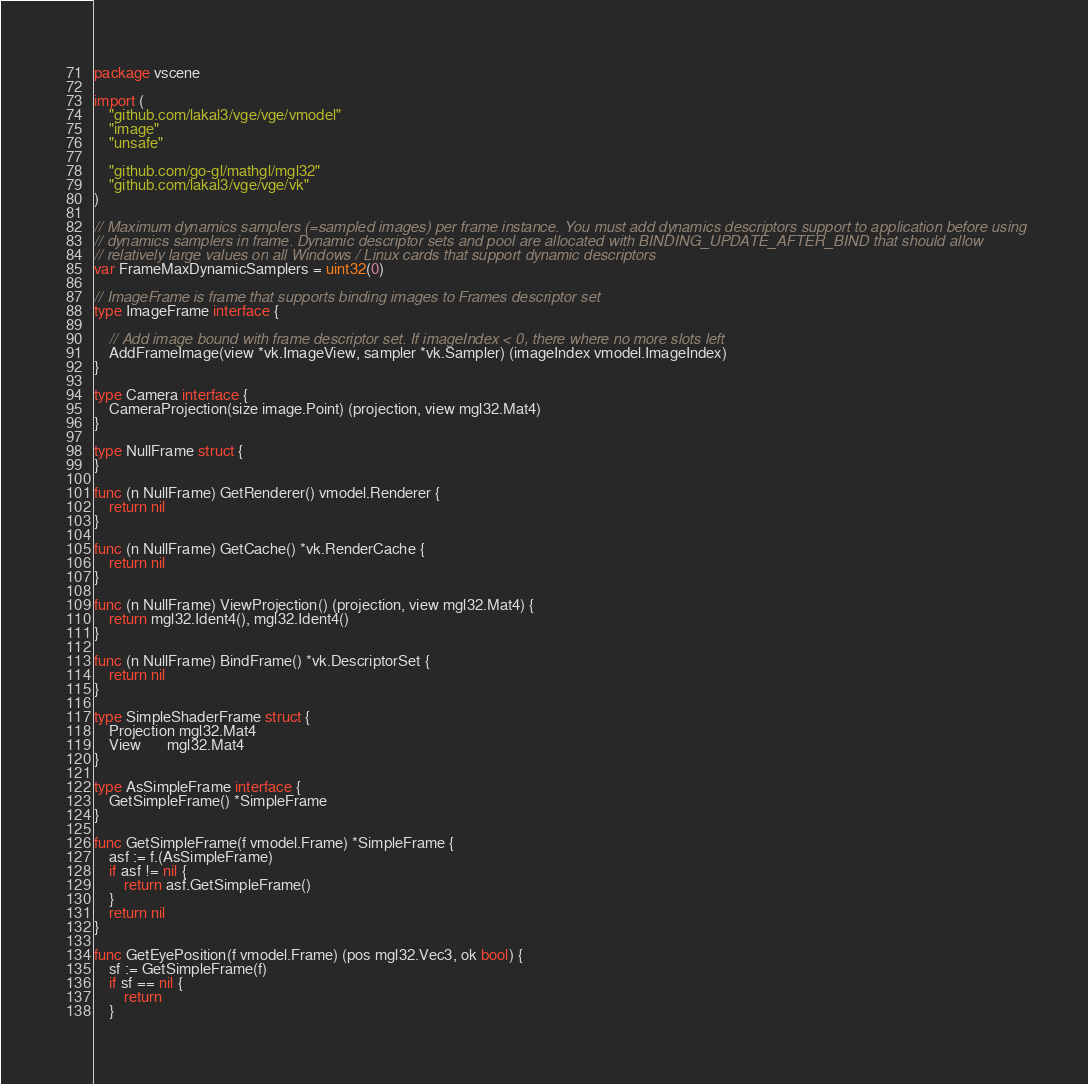Convert code to text. <code><loc_0><loc_0><loc_500><loc_500><_Go_>package vscene

import (
	"github.com/lakal3/vge/vge/vmodel"
	"image"
	"unsafe"

	"github.com/go-gl/mathgl/mgl32"
	"github.com/lakal3/vge/vge/vk"
)

// Maximum dynamics samplers (=sampled images) per frame instance. You must add dynamics descriptors support to application before using
// dynamics samplers in frame. Dynamic descriptor sets and pool are allocated with BINDING_UPDATE_AFTER_BIND that should allow
// relatively large values on all Windows / Linux cards that support dynamic descriptors
var FrameMaxDynamicSamplers = uint32(0)

// ImageFrame is frame that supports binding images to Frames descriptor set
type ImageFrame interface {

	// Add image bound with frame descriptor set. If imageIndex < 0, there where no more slots left
	AddFrameImage(view *vk.ImageView, sampler *vk.Sampler) (imageIndex vmodel.ImageIndex)
}

type Camera interface {
	CameraProjection(size image.Point) (projection, view mgl32.Mat4)
}

type NullFrame struct {
}

func (n NullFrame) GetRenderer() vmodel.Renderer {
	return nil
}

func (n NullFrame) GetCache() *vk.RenderCache {
	return nil
}

func (n NullFrame) ViewProjection() (projection, view mgl32.Mat4) {
	return mgl32.Ident4(), mgl32.Ident4()
}

func (n NullFrame) BindFrame() *vk.DescriptorSet {
	return nil
}

type SimpleShaderFrame struct {
	Projection mgl32.Mat4
	View       mgl32.Mat4
}

type AsSimpleFrame interface {
	GetSimpleFrame() *SimpleFrame
}

func GetSimpleFrame(f vmodel.Frame) *SimpleFrame {
	asf := f.(AsSimpleFrame)
	if asf != nil {
		return asf.GetSimpleFrame()
	}
	return nil
}

func GetEyePosition(f vmodel.Frame) (pos mgl32.Vec3, ok bool) {
	sf := GetSimpleFrame(f)
	if sf == nil {
		return
	}</code> 